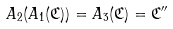Convert formula to latex. <formula><loc_0><loc_0><loc_500><loc_500>A _ { 2 } ( A _ { 1 } ( \mathfrak { C } ) ) = A _ { 3 } ( \mathfrak { C } ) = \mathfrak { C } ^ { \prime \prime }</formula> 